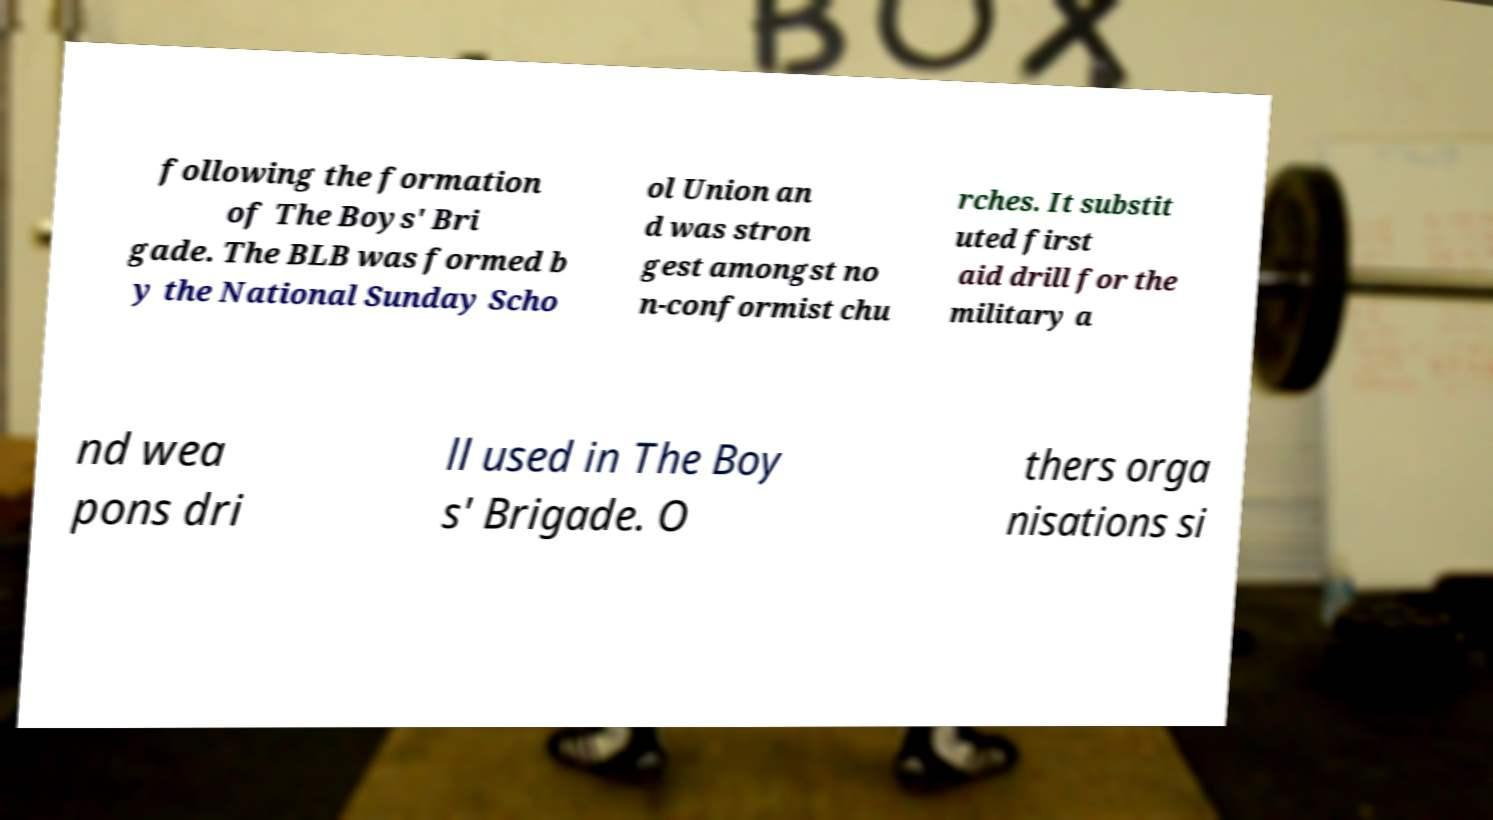Please identify and transcribe the text found in this image. following the formation of The Boys' Bri gade. The BLB was formed b y the National Sunday Scho ol Union an d was stron gest amongst no n-conformist chu rches. It substit uted first aid drill for the military a nd wea pons dri ll used in The Boy s' Brigade. O thers orga nisations si 